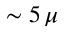<formula> <loc_0><loc_0><loc_500><loc_500>\sim 5 \, \mu</formula> 